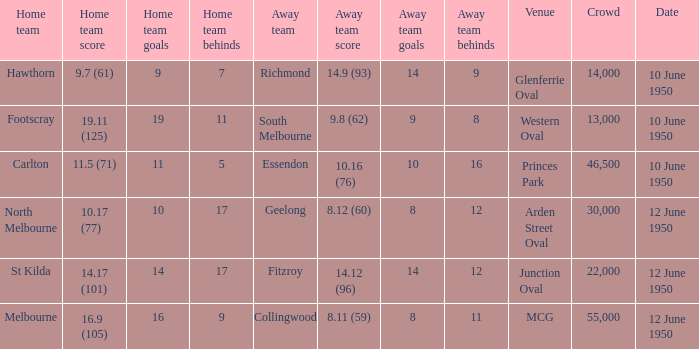Who was the away team when the VFL played at MCG? Collingwood. 